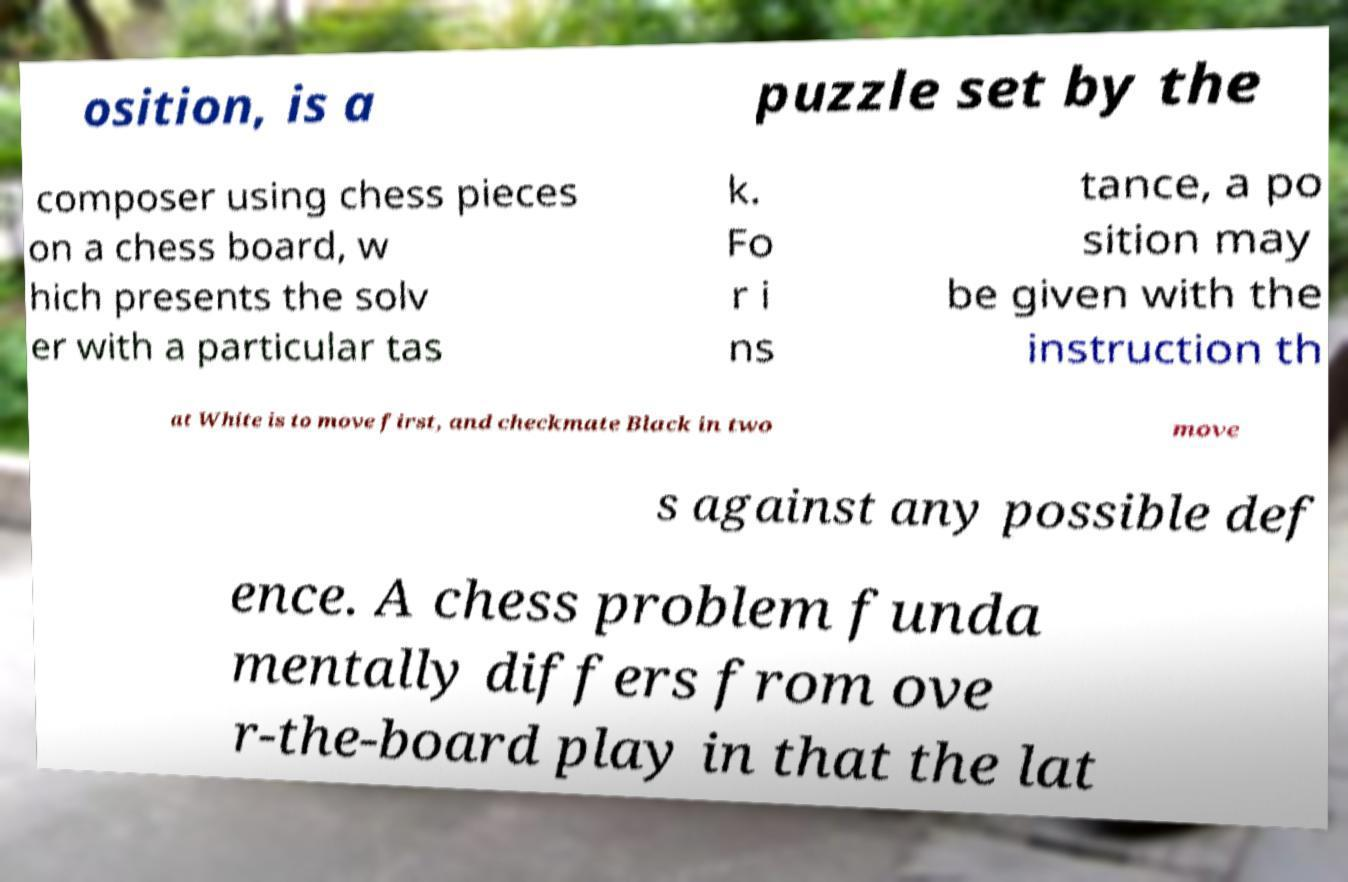Please identify and transcribe the text found in this image. osition, is a puzzle set by the composer using chess pieces on a chess board, w hich presents the solv er with a particular tas k. Fo r i ns tance, a po sition may be given with the instruction th at White is to move first, and checkmate Black in two move s against any possible def ence. A chess problem funda mentally differs from ove r-the-board play in that the lat 